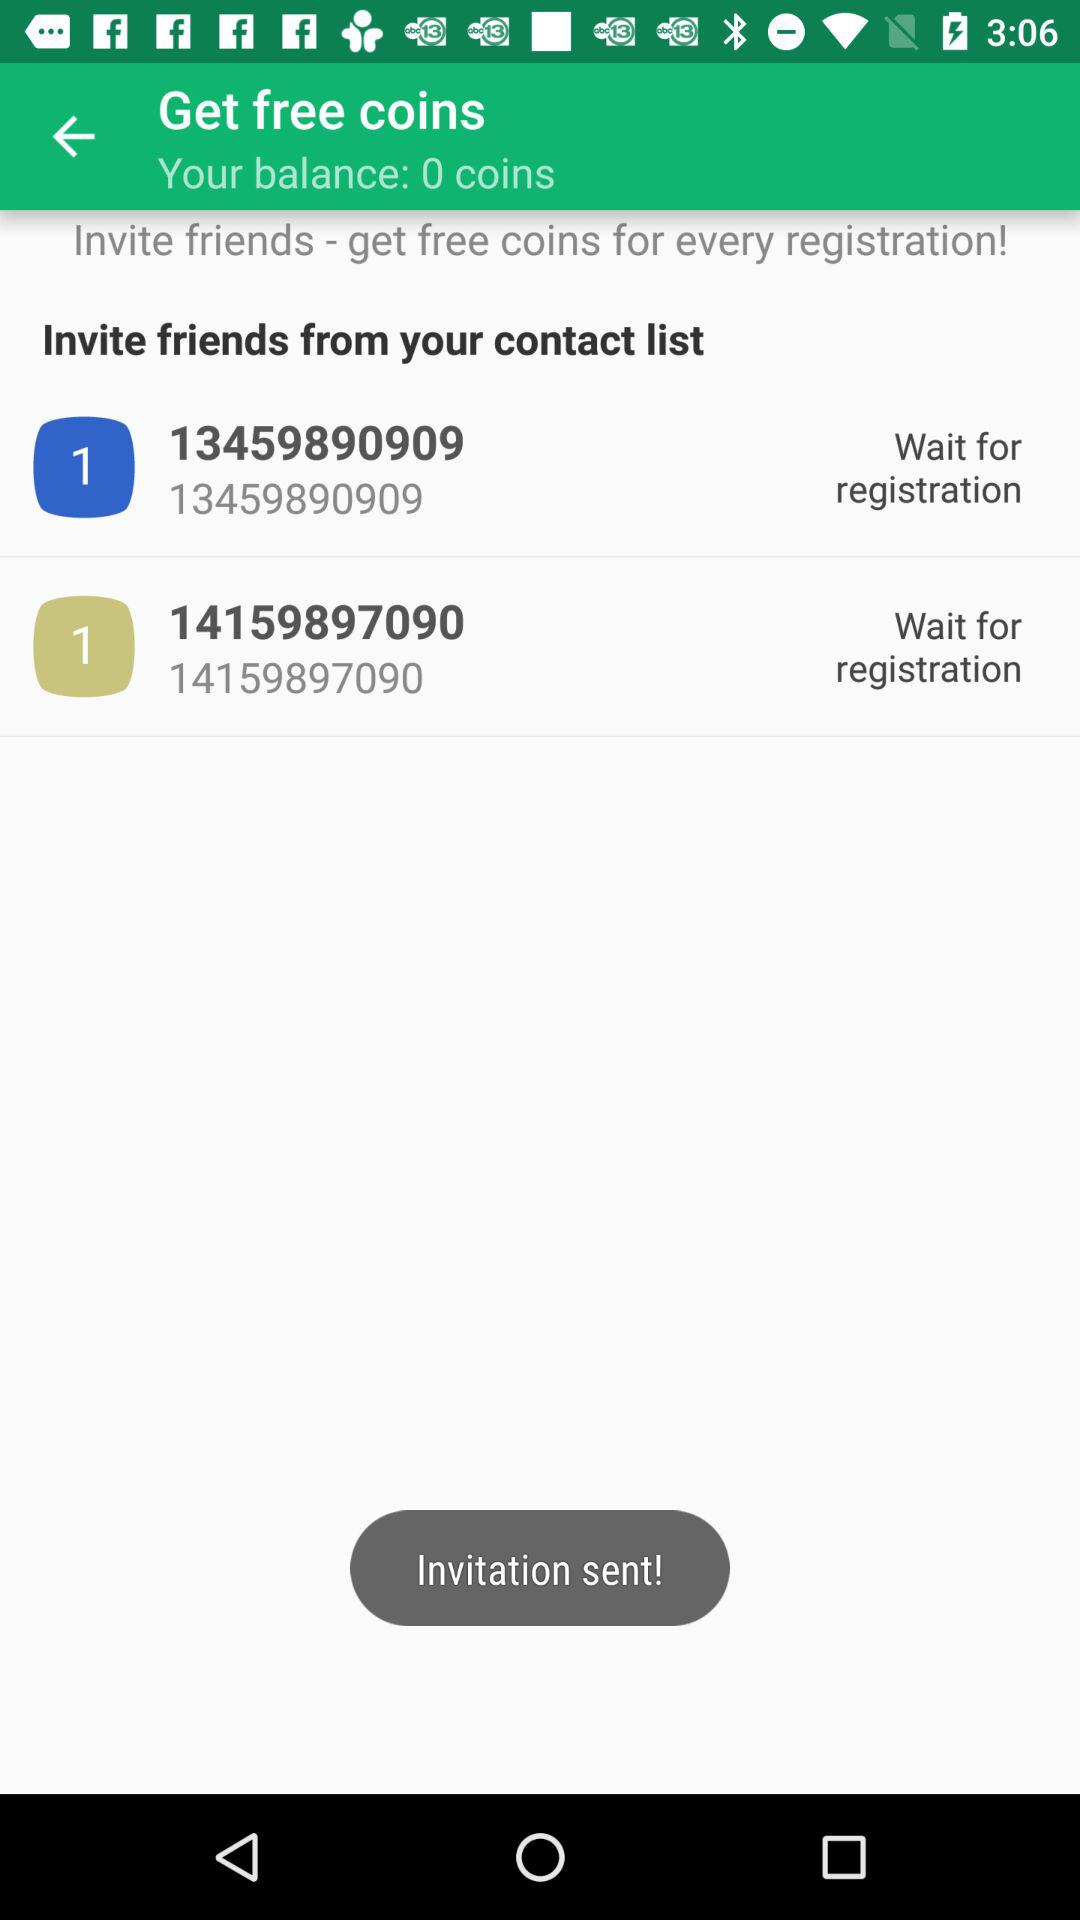What is the coin balance? The balance is 0. 